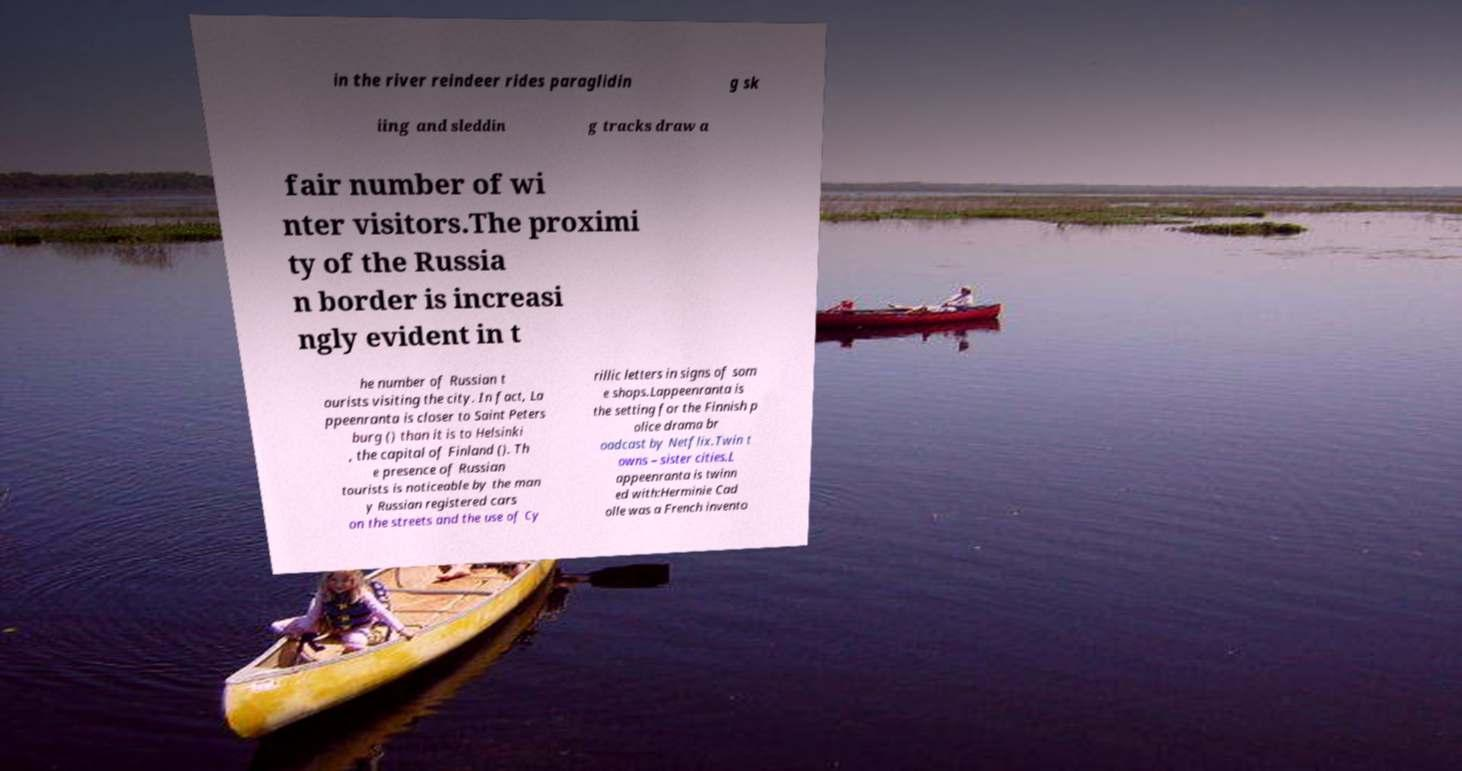Can you accurately transcribe the text from the provided image for me? in the river reindeer rides paraglidin g sk iing and sleddin g tracks draw a fair number of wi nter visitors.The proximi ty of the Russia n border is increasi ngly evident in t he number of Russian t ourists visiting the city. In fact, La ppeenranta is closer to Saint Peters burg () than it is to Helsinki , the capital of Finland (). Th e presence of Russian tourists is noticeable by the man y Russian registered cars on the streets and the use of Cy rillic letters in signs of som e shops.Lappeenranta is the setting for the Finnish p olice drama br oadcast by Netflix.Twin t owns – sister cities.L appeenranta is twinn ed with:Herminie Cad olle was a French invento 